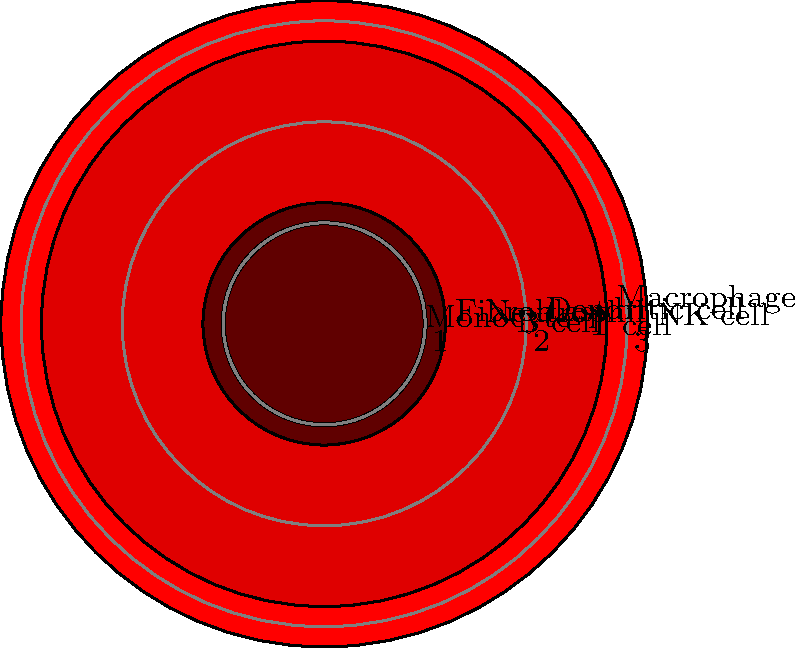In the circular heatmap showing gene expression levels across different cell types, which cell type exhibits the highest expression level for the gene of interest? To determine the cell type with the highest gene expression level, we need to analyze the circular heatmap:

1. The heatmap represents gene expression levels for 8 different cell types.
2. Each cell type is positioned radially around the circle.
3. The intensity of the red color and the distance from the center indicate the expression level.
4. The concentric circles represent expression levels of 1, 2, and 3.

Examining the heatmap:
1. T cell: Moderate expression (between 2 and 3)
2. B cell: Low-moderate expression (between 1 and 2)
3. NK cell: Highest expression (beyond 3)
4. Monocyte: Low expression (below 1)
5. Neutrophil: Low-moderate expression (between 1 and 2)
6. Dendritic cell: Moderate expression (around 2)
7. Macrophage: High expression (between 2 and 3)
8. Fibroblast: Low-moderate expression (around 1)

The NK cell shows the largest and most intensely colored circle, extending beyond the outermost concentric circle (level 3).
Answer: NK cell 